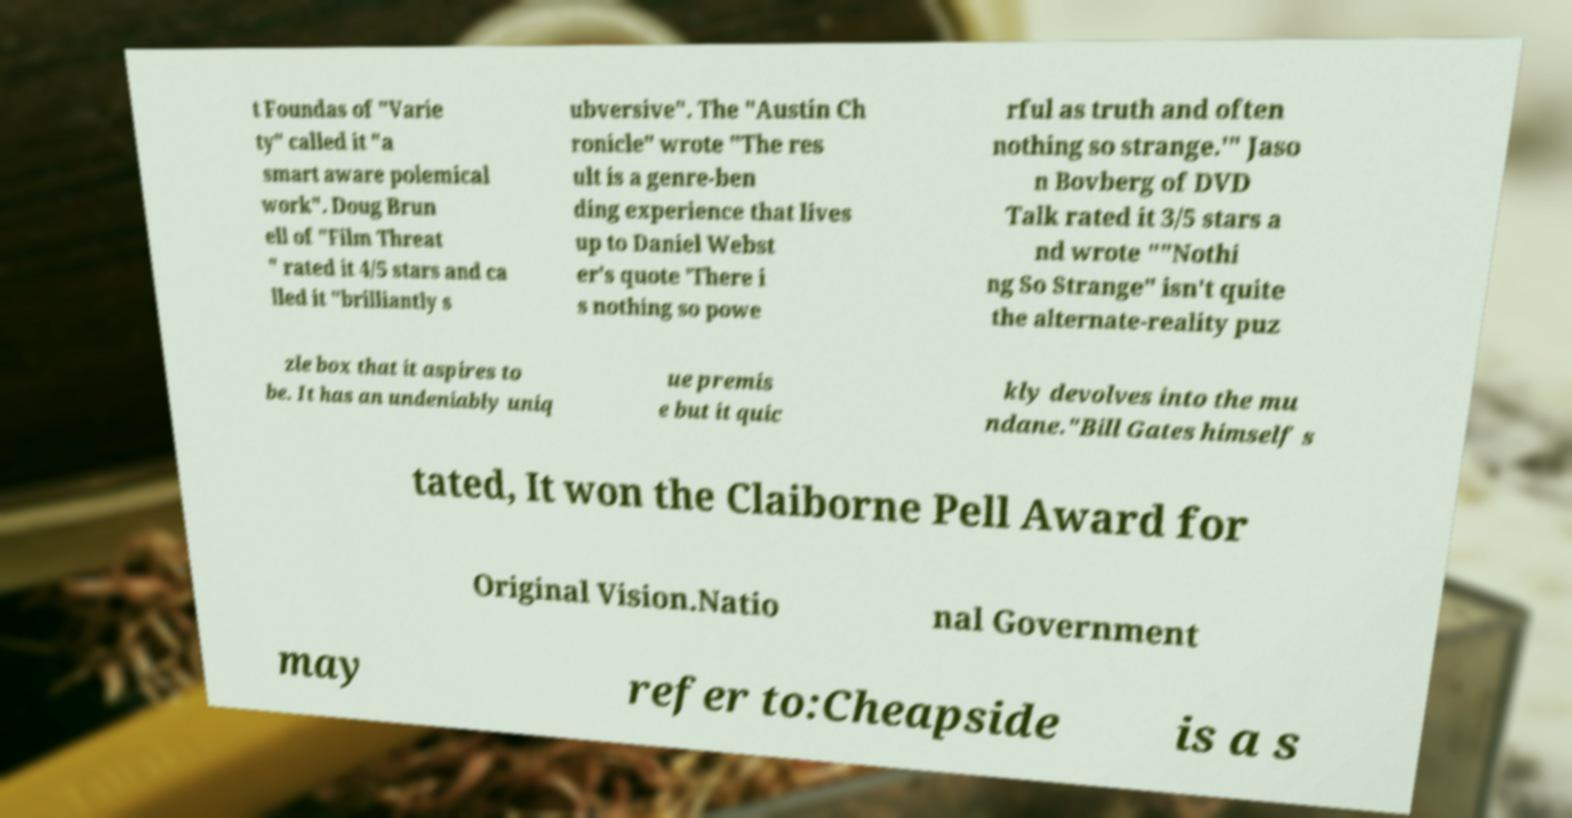For documentation purposes, I need the text within this image transcribed. Could you provide that? t Foundas of "Varie ty" called it "a smart aware polemical work". Doug Brun ell of "Film Threat " rated it 4/5 stars and ca lled it "brilliantly s ubversive". The "Austin Ch ronicle" wrote "The res ult is a genre-ben ding experience that lives up to Daniel Webst er's quote 'There i s nothing so powe rful as truth and often nothing so strange.'" Jaso n Bovberg of DVD Talk rated it 3/5 stars a nd wrote ""Nothi ng So Strange" isn't quite the alternate-reality puz zle box that it aspires to be. It has an undeniably uniq ue premis e but it quic kly devolves into the mu ndane."Bill Gates himself s tated, It won the Claiborne Pell Award for Original Vision.Natio nal Government may refer to:Cheapside is a s 